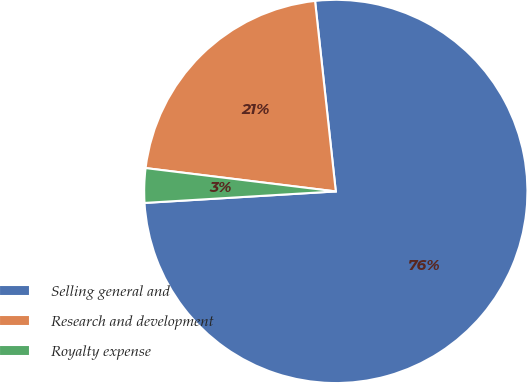Convert chart. <chart><loc_0><loc_0><loc_500><loc_500><pie_chart><fcel>Selling general and<fcel>Research and development<fcel>Royalty expense<nl><fcel>75.77%<fcel>21.33%<fcel>2.9%<nl></chart> 